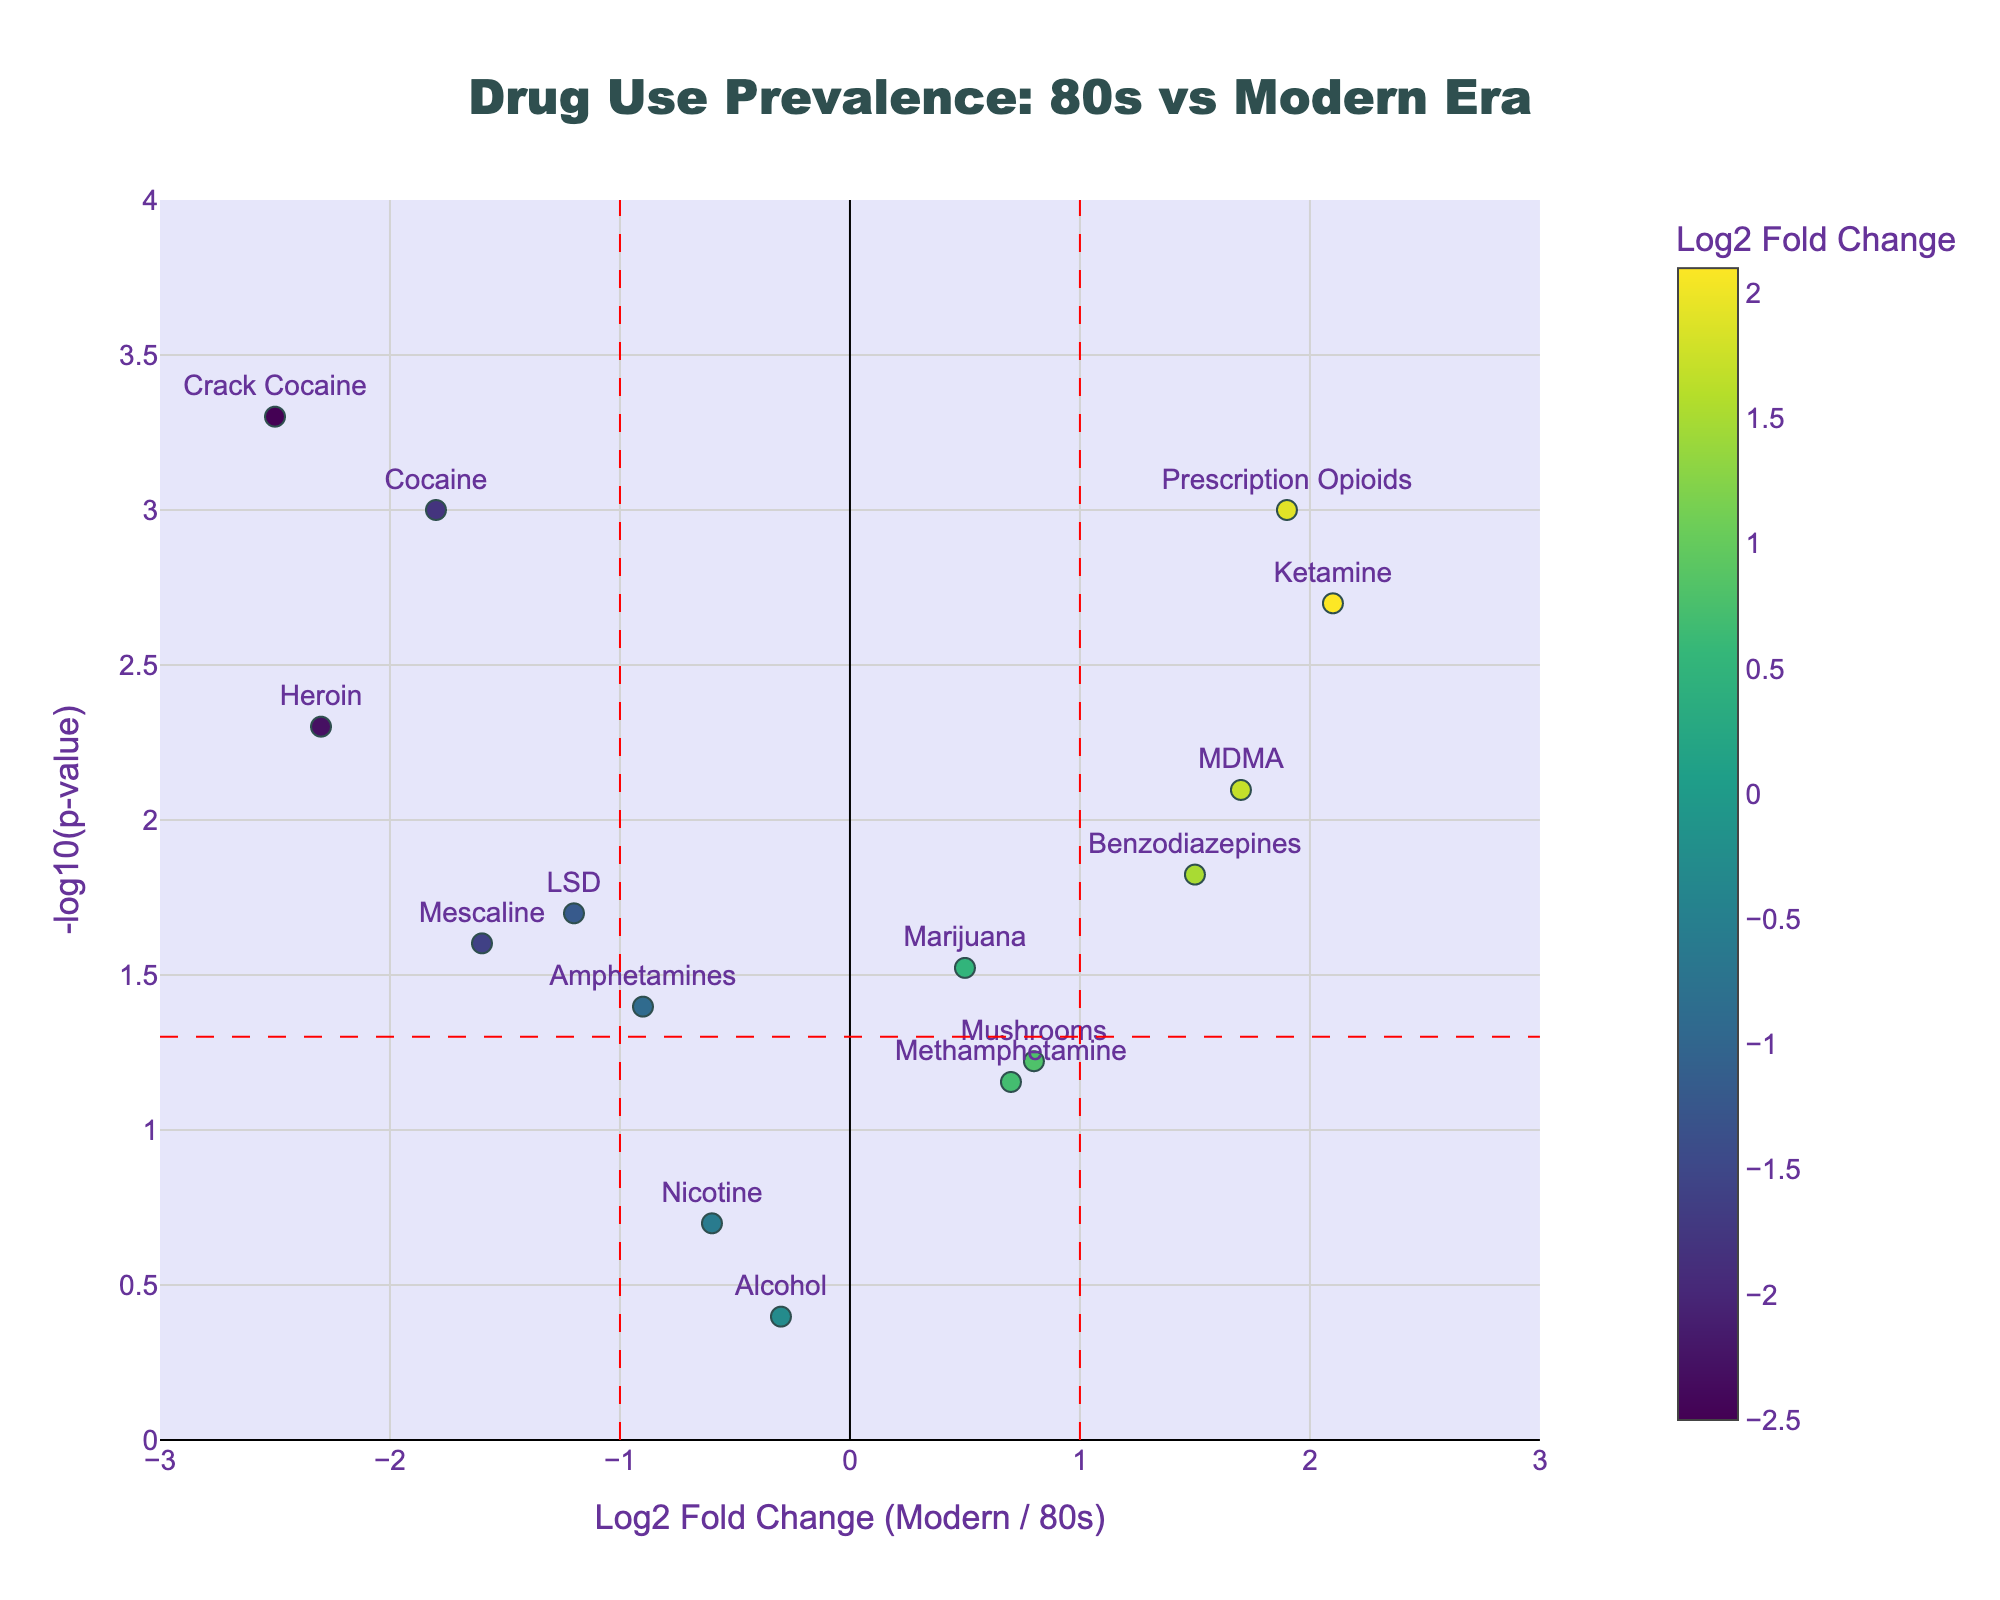What is the title of the plot? The title is located at the top of the figure, typically centered. Look for the largest text to identify it.
Answer: Drug Use Prevalence: 80s vs Modern Era Which drugs show increased prevalence in modern times compared to the 80s? We look for drugs with a Log2 Fold Change greater than 0. These are positioned on the right side of the plot.
Answer: Marijuana, MDMA, Ketamine, Prescription Opioids, Benzodiazepines, Mushrooms, Methamphetamine Which drug has the highest statistical significance in decreased prevalence from the 80s to modern era? The significance is shown by the highest value on the y-axis. Look for the highest point among the drugs with a negative Log2 Fold Change.
Answer: Crack Cocaine How many drugs have a p-value < 0.05? Look for data points above the horizontal line indicating p = 0.05. Count all these points.
Answer: 10 Which drugs have a decrease in prevalence and are statistically significant (p-value < 0.05)? Look for drugs with Log2 Fold Change less than 0 (left of the plot) and positioned above the horizontal line.
Answer: Cocaine, Heroin, LSD, Amphetamines, Mescaline, Crack Cocaine Between Marijuana and Alcohol, which has a higher increase in prevalence in modern times? Compare their Log2 Fold Change values. Marijuana's bar is on the positive side (right), and Alcohol's is on the negative side (left).
Answer: Marijuana What is the Log2 Fold Change threshold indicated by vertical dashed lines? The vertical dashed lines are markers for specific Log2 Fold Change values. Identify the values where these lines are placed.
Answer: -1 and 1 Which drug shows the greatest increase in prevalence in modern times compared to the 80s? Look for the drug with the highest positive value on the x-axis (rightmost point on the plot).
Answer: Ketamine Is Nicotine's prevalence significantly different between the 80s and the modern era? Check if the point representing Nicotine is above the horizontal dashed line (p-value < 0.05).
Answer: No Which drugs have decreased prevalence but are not statistically significant (p-value > 0.05)? Look for drugs with Log2 Fold Change less than 0 and positioned below the horizontal line.
Answer: Alcohol, Nicotine 